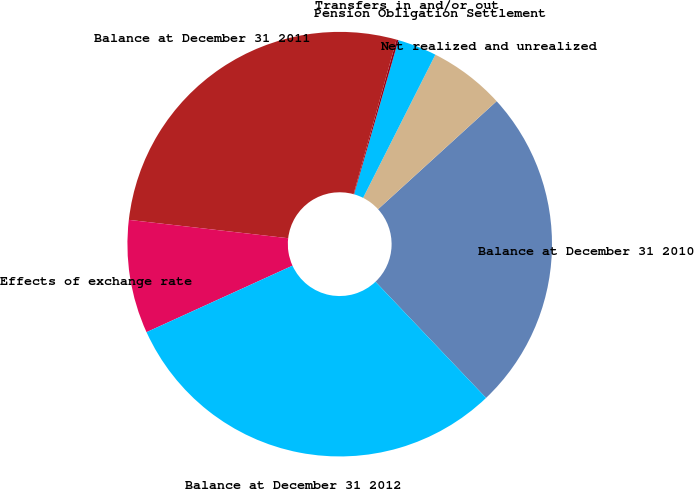Convert chart. <chart><loc_0><loc_0><loc_500><loc_500><pie_chart><fcel>Balance at December 31 2010<fcel>Net realized and unrealized<fcel>Pension Obligation Settlement<fcel>Transfers in and/or out<fcel>Balance at December 31 2011<fcel>Effects of exchange rate<fcel>Balance at December 31 2012<nl><fcel>24.65%<fcel>5.8%<fcel>2.98%<fcel>0.15%<fcel>27.48%<fcel>8.63%<fcel>30.3%<nl></chart> 